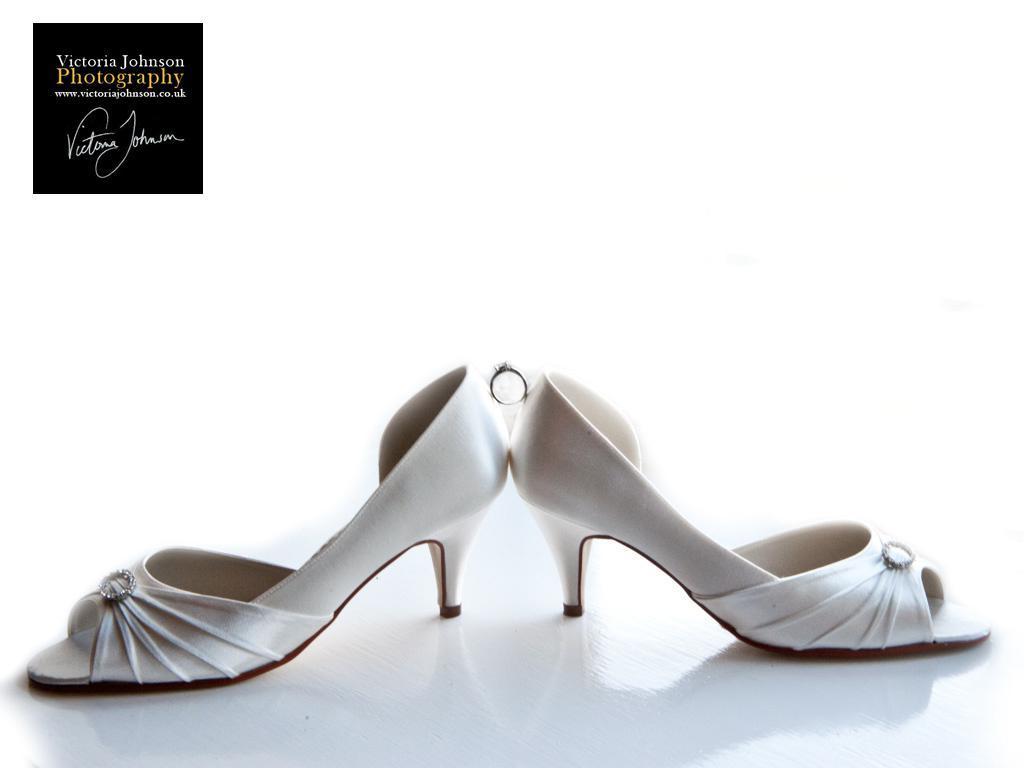Describe this image in one or two sentences. In this picture we can see few heels, on top of the image we can find some text. 